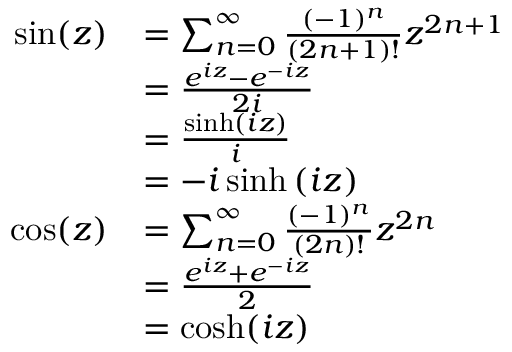Convert formula to latex. <formula><loc_0><loc_0><loc_500><loc_500>{ \begin{array} { r l } { \sin ( z ) } & { = \sum _ { n = 0 } ^ { \infty } { \frac { ( - 1 ) ^ { n } } { ( 2 n + 1 ) ! } } z ^ { 2 n + 1 } } \\ & { = { \frac { e ^ { i z } - e ^ { - i z } } { 2 i } } } \\ & { = { \frac { \sinh \left ( i z \right ) } { i } } } \\ & { = - i \sinh \left ( i z \right ) } \\ { \cos ( z ) } & { = \sum _ { n = 0 } ^ { \infty } { \frac { ( - 1 ) ^ { n } } { ( 2 n ) ! } } z ^ { 2 n } } \\ & { = { \frac { e ^ { i z } + e ^ { - i z } } { 2 } } } \\ & { = \cosh ( i z ) } \end{array} }</formula> 